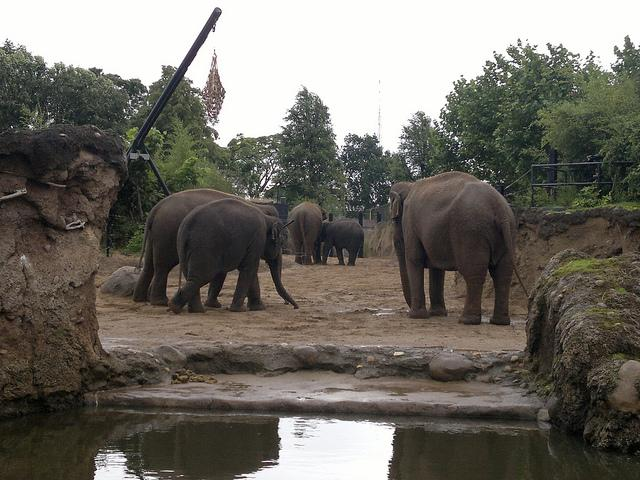What measurement is closest to the weight of the biggest animal here? ton 